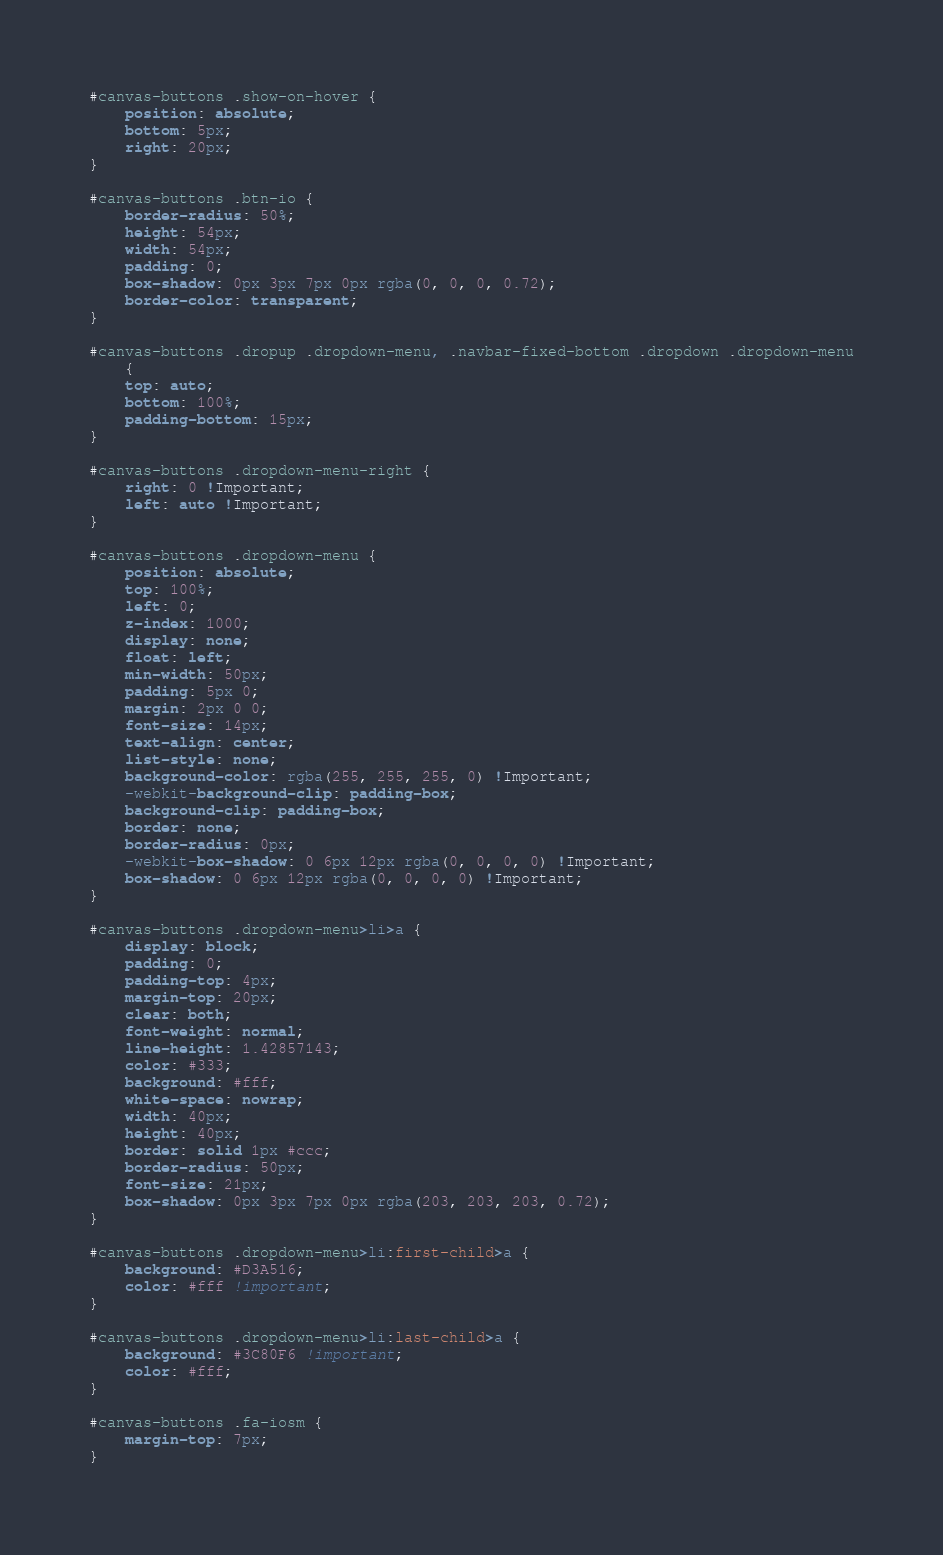<code> <loc_0><loc_0><loc_500><loc_500><_CSS_>
#canvas-buttons .show-on-hover {
	position: absolute;
	bottom: 5px;
	right: 20px;
}

#canvas-buttons .btn-io {
	border-radius: 50%;
	height: 54px;
	width: 54px;
	padding: 0;
	box-shadow: 0px 3px 7px 0px rgba(0, 0, 0, 0.72);
	border-color: transparent;
}

#canvas-buttons .dropup .dropdown-menu, .navbar-fixed-bottom .dropdown .dropdown-menu
	{
	top: auto;
	bottom: 100%;
	padding-bottom: 15px;
}

#canvas-buttons .dropdown-menu-right {
	right: 0 !Important;
	left: auto !Important;
}

#canvas-buttons .dropdown-menu {
	position: absolute;
	top: 100%;
	left: 0;
	z-index: 1000;
	display: none;
	float: left;
	min-width: 50px;
	padding: 5px 0;
	margin: 2px 0 0;
	font-size: 14px;
	text-align: center;
	list-style: none;
	background-color: rgba(255, 255, 255, 0) !Important;
	-webkit-background-clip: padding-box;
	background-clip: padding-box;
	border: none;
	border-radius: 0px;
	-webkit-box-shadow: 0 6px 12px rgba(0, 0, 0, 0) !Important;
	box-shadow: 0 6px 12px rgba(0, 0, 0, 0) !Important;
}

#canvas-buttons .dropdown-menu>li>a {
	display: block;
	padding: 0;
	padding-top: 4px;
	margin-top: 20px;
	clear: both;
	font-weight: normal;
	line-height: 1.42857143;
	color: #333;
	background: #fff;
	white-space: nowrap;
	width: 40px;
	height: 40px;
	border: solid 1px #ccc;
	border-radius: 50px;
	font-size: 21px;
	box-shadow: 0px 3px 7px 0px rgba(203, 203, 203, 0.72);
}

#canvas-buttons .dropdown-menu>li:first-child>a {
	background: #D3A516;
	color: #fff !important;
}

#canvas-buttons .dropdown-menu>li:last-child>a {
	background: #3C80F6 !important;
	color: #fff;
}

#canvas-buttons .fa-iosm {
	margin-top: 7px;
}</code> 